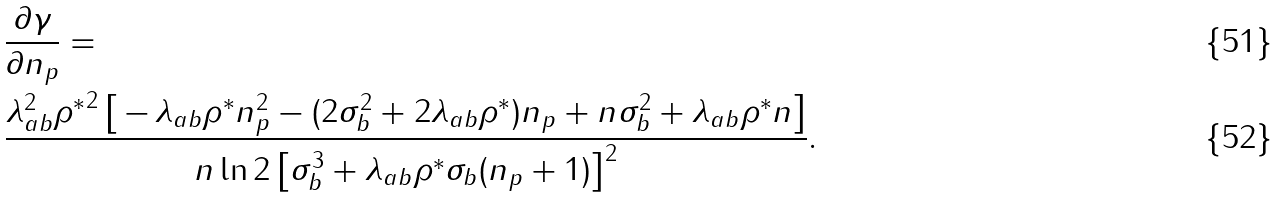Convert formula to latex. <formula><loc_0><loc_0><loc_500><loc_500>& \frac { \partial \gamma } { \partial n _ { p } } = \\ & \frac { \lambda _ { a b } ^ { 2 } { \rho ^ { \ast } } ^ { 2 } \left [ \, - \, \lambda _ { a b } \rho ^ { \ast } n _ { p } ^ { 2 } - ( 2 \sigma _ { b } ^ { 2 } + 2 \lambda _ { a b } \rho ^ { \ast } ) n _ { p } + n \sigma _ { b } ^ { 2 } + \lambda _ { a b } \rho ^ { \ast } n \right ] } { n \ln 2 \left [ \sigma _ { b } ^ { 3 } + \lambda _ { a b } \rho ^ { \ast } \sigma _ { b } ( n _ { p } + 1 ) \right ] ^ { 2 } } .</formula> 